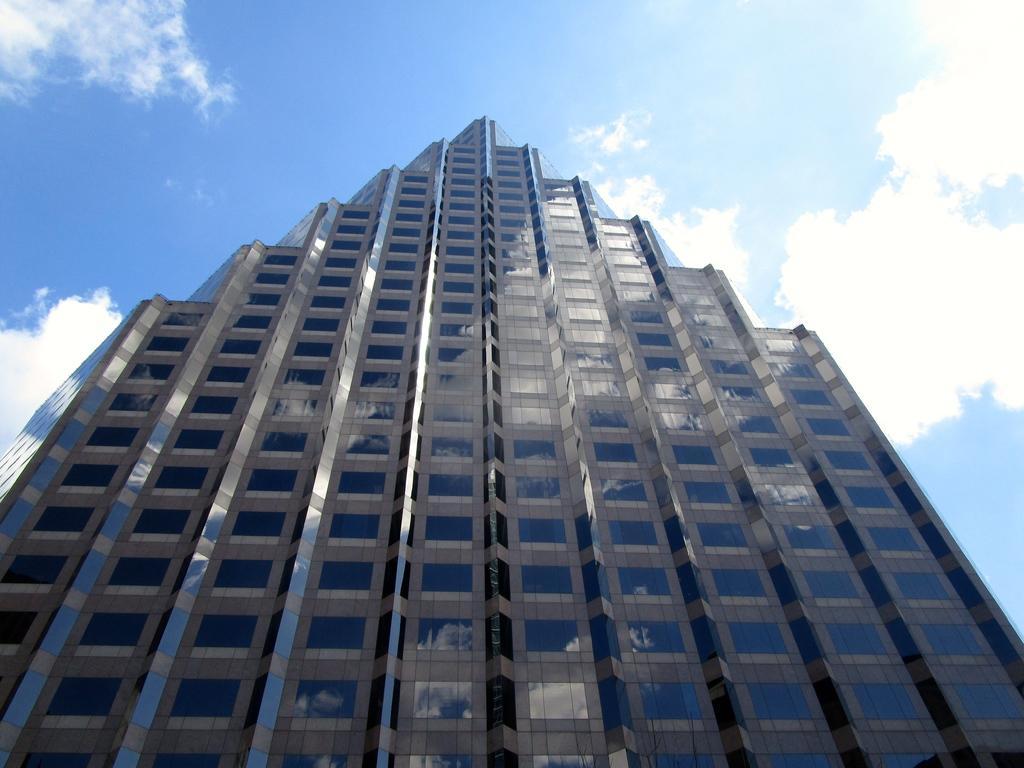Could you give a brief overview of what you see in this image? In this image, we can see a glass building. Background we can see the cloudy sky. 